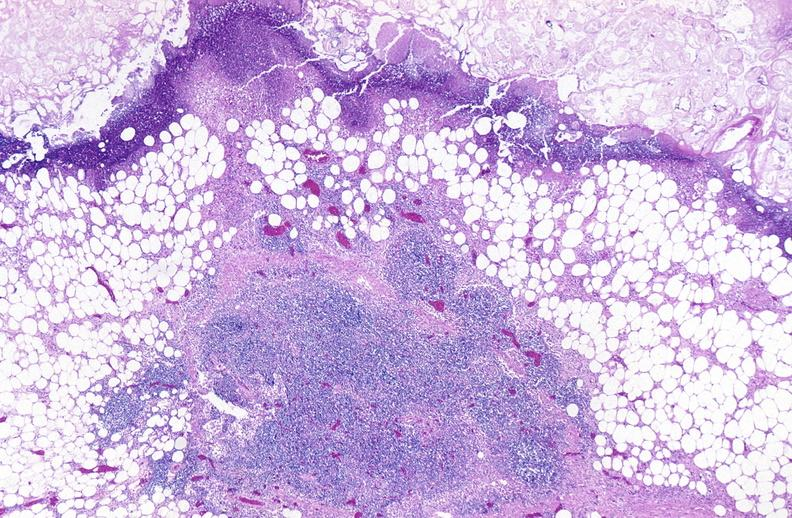what does this image show?
Answer the question using a single word or phrase. Pancreatic fat necrosis 